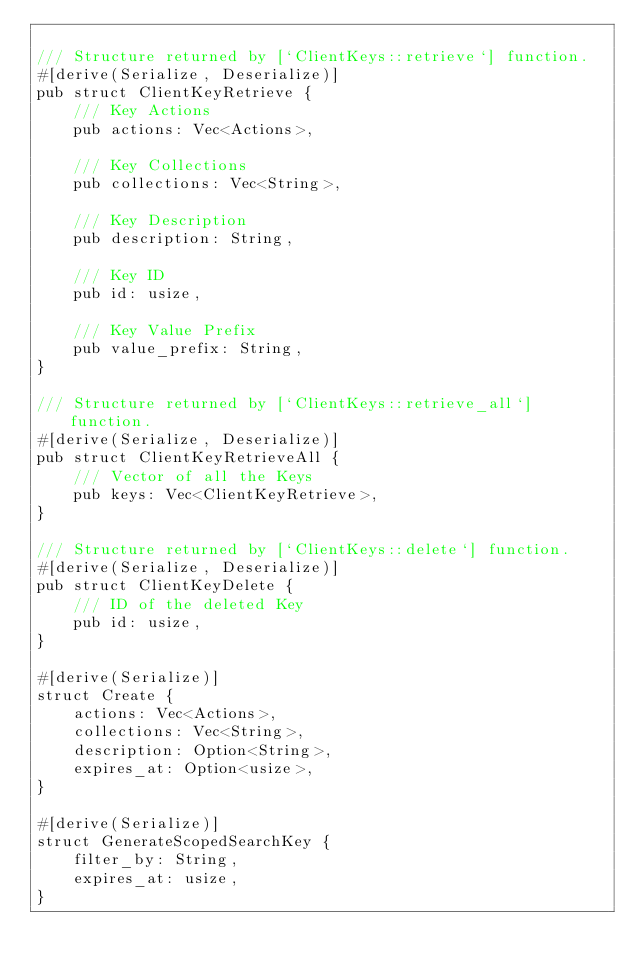Convert code to text. <code><loc_0><loc_0><loc_500><loc_500><_Rust_>
/// Structure returned by [`ClientKeys::retrieve`] function.
#[derive(Serialize, Deserialize)]
pub struct ClientKeyRetrieve {
    /// Key Actions
    pub actions: Vec<Actions>,

    /// Key Collections
    pub collections: Vec<String>,

    /// Key Description
    pub description: String,

    /// Key ID
    pub id: usize,

    /// Key Value Prefix
    pub value_prefix: String,
}

/// Structure returned by [`ClientKeys::retrieve_all`] function.
#[derive(Serialize, Deserialize)]
pub struct ClientKeyRetrieveAll {
    /// Vector of all the Keys
    pub keys: Vec<ClientKeyRetrieve>,
}

/// Structure returned by [`ClientKeys::delete`] function.
#[derive(Serialize, Deserialize)]
pub struct ClientKeyDelete {
    /// ID of the deleted Key
    pub id: usize,
}

#[derive(Serialize)]
struct Create {
    actions: Vec<Actions>,
    collections: Vec<String>,
    description: Option<String>,
    expires_at: Option<usize>,
}

#[derive(Serialize)]
struct GenerateScopedSearchKey {
    filter_by: String,
    expires_at: usize,
}
</code> 